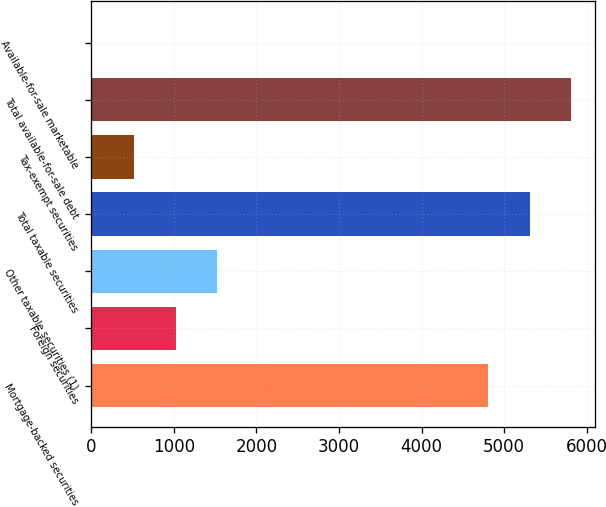Convert chart to OTSL. <chart><loc_0><loc_0><loc_500><loc_500><bar_chart><fcel>Mortgage-backed securities<fcel>Foreign securities<fcel>Other taxable securities (1)<fcel>Total taxable securities<fcel>Tax-exempt securities<fcel>Total available-for-sale debt<fcel>Available-for-sale marketable<nl><fcel>4804<fcel>1019.8<fcel>1524.7<fcel>5308.9<fcel>514.9<fcel>5813.8<fcel>10<nl></chart> 